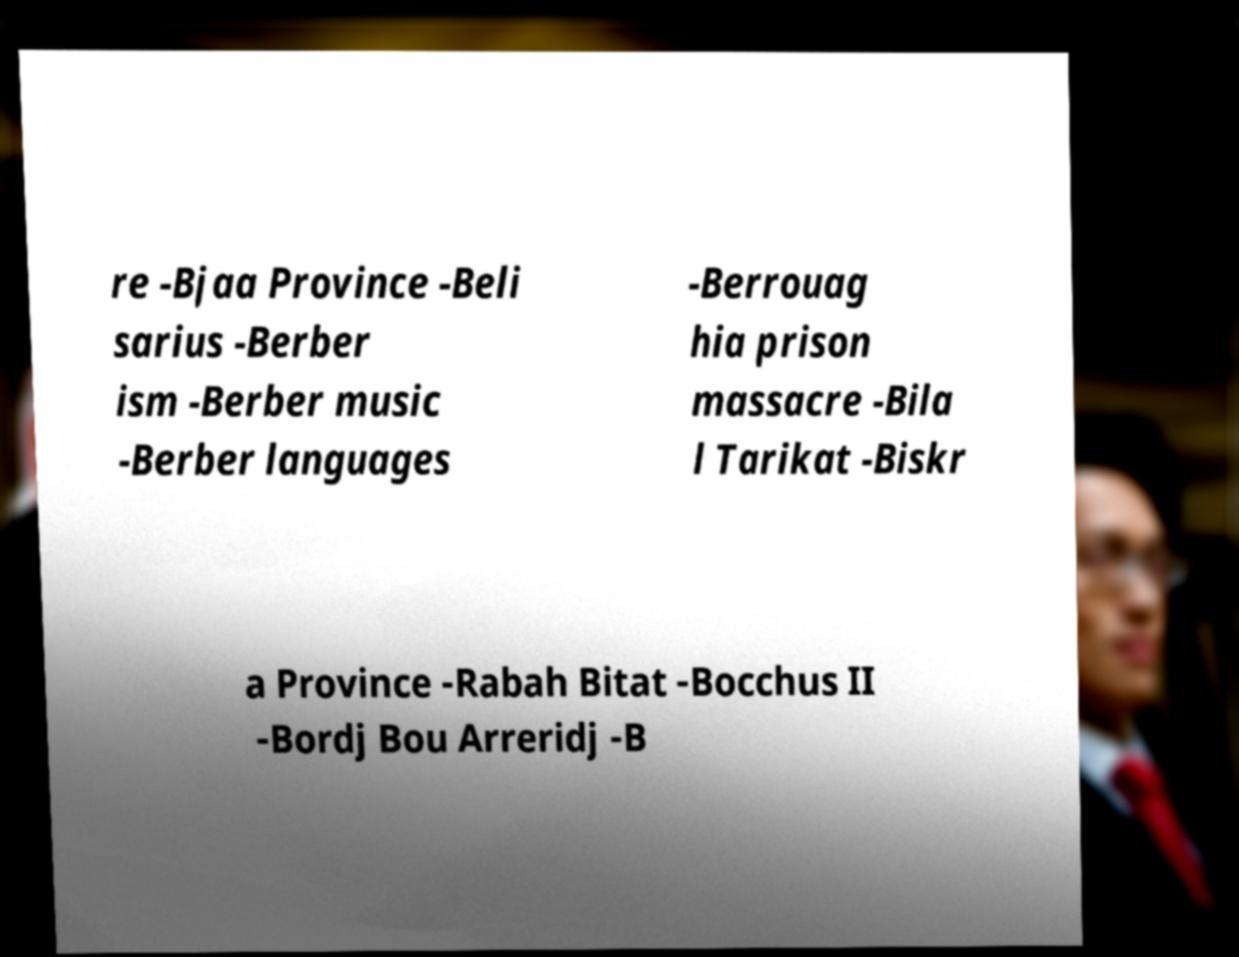Could you extract and type out the text from this image? re -Bjaa Province -Beli sarius -Berber ism -Berber music -Berber languages -Berrouag hia prison massacre -Bila l Tarikat -Biskr a Province -Rabah Bitat -Bocchus II -Bordj Bou Arreridj -B 